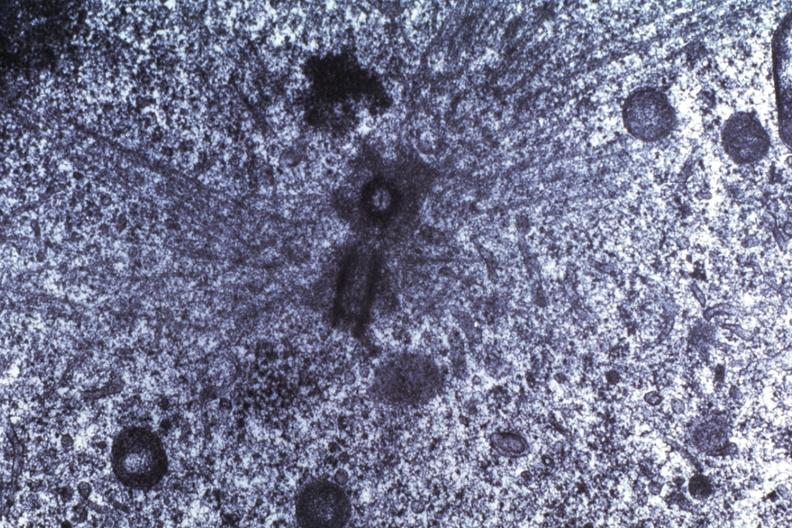s side showing patency right side present?
Answer the question using a single word or phrase. No 